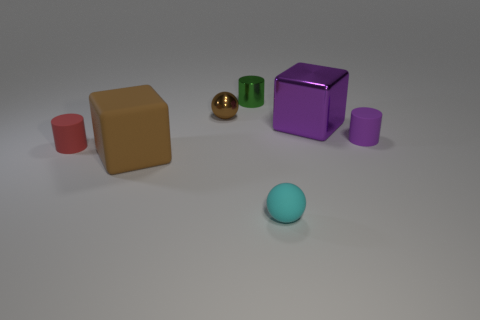Add 1 large purple shiny things. How many objects exist? 8 Subtract all rubber cylinders. How many cylinders are left? 1 Subtract all green cylinders. How many cylinders are left? 2 Subtract 0 gray cylinders. How many objects are left? 7 Subtract all cylinders. How many objects are left? 4 Subtract 1 cylinders. How many cylinders are left? 2 Subtract all red spheres. Subtract all yellow cubes. How many spheres are left? 2 Subtract all gray cylinders. How many blue blocks are left? 0 Subtract all purple objects. Subtract all brown objects. How many objects are left? 3 Add 7 small purple matte things. How many small purple matte things are left? 8 